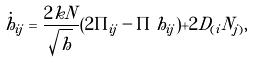<formula> <loc_0><loc_0><loc_500><loc_500>\dot { h } _ { i j } = \frac { 2 k N } { \sqrt { h } } ( 2 \Pi _ { i j } - \Pi \, h _ { i j } ) + 2 D _ { ( i } N _ { j ) } ,</formula> 